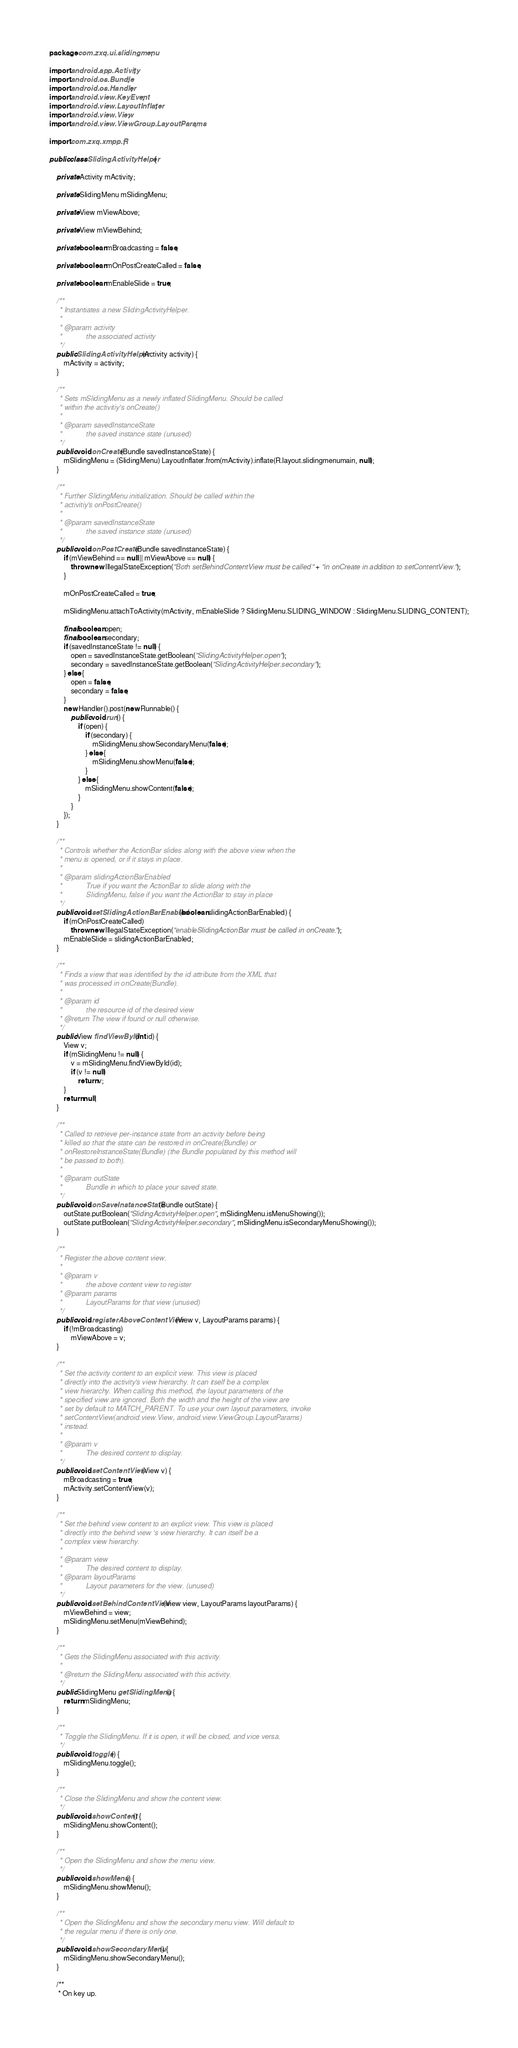<code> <loc_0><loc_0><loc_500><loc_500><_Java_>package com.zxq.ui.slidingmenu;

import android.app.Activity;
import android.os.Bundle;
import android.os.Handler;
import android.view.KeyEvent;
import android.view.LayoutInflater;
import android.view.View;
import android.view.ViewGroup.LayoutParams;

import com.zxq.xmpp.R;

public class SlidingActivityHelper {

	private Activity mActivity;

	private SlidingMenu mSlidingMenu;

	private View mViewAbove;

	private View mViewBehind;

	private boolean mBroadcasting = false;

	private boolean mOnPostCreateCalled = false;

	private boolean mEnableSlide = true;

	/**
	 * Instantiates a new SlidingActivityHelper.
	 * 
	 * @param activity
	 *            the associated activity
	 */
	public SlidingActivityHelper(Activity activity) {
		mActivity = activity;
	}

	/**
	 * Sets mSlidingMenu as a newly inflated SlidingMenu. Should be called
	 * within the activitiy's onCreate()
	 * 
	 * @param savedInstanceState
	 *            the saved instance state (unused)
	 */
	public void onCreate(Bundle savedInstanceState) {
		mSlidingMenu = (SlidingMenu) LayoutInflater.from(mActivity).inflate(R.layout.slidingmenumain, null);
	}

	/**
	 * Further SlidingMenu initialization. Should be called within the
	 * activitiy's onPostCreate()
	 * 
	 * @param savedInstanceState
	 *            the saved instance state (unused)
	 */
	public void onPostCreate(Bundle savedInstanceState) {
		if (mViewBehind == null || mViewAbove == null) {
			throw new IllegalStateException("Both setBehindContentView must be called " + "in onCreate in addition to setContentView.");
		}

		mOnPostCreateCalled = true;

		mSlidingMenu.attachToActivity(mActivity, mEnableSlide ? SlidingMenu.SLIDING_WINDOW : SlidingMenu.SLIDING_CONTENT);

		final boolean open;
		final boolean secondary;
		if (savedInstanceState != null) {
			open = savedInstanceState.getBoolean("SlidingActivityHelper.open");
			secondary = savedInstanceState.getBoolean("SlidingActivityHelper.secondary");
		} else {
			open = false;
			secondary = false;
		}
		new Handler().post(new Runnable() {
			public void run() {
				if (open) {
					if (secondary) {
						mSlidingMenu.showSecondaryMenu(false);
					} else {
						mSlidingMenu.showMenu(false);
					}
				} else {
					mSlidingMenu.showContent(false);
				}
			}
		});
	}

	/**
	 * Controls whether the ActionBar slides along with the above view when the
	 * menu is opened, or if it stays in place.
	 * 
	 * @param slidingActionBarEnabled
	 *            True if you want the ActionBar to slide along with the
	 *            SlidingMenu, false if you want the ActionBar to stay in place
	 */
	public void setSlidingActionBarEnabled(boolean slidingActionBarEnabled) {
		if (mOnPostCreateCalled)
			throw new IllegalStateException("enableSlidingActionBar must be called in onCreate.");
		mEnableSlide = slidingActionBarEnabled;
	}

	/**
	 * Finds a view that was identified by the id attribute from the XML that
	 * was processed in onCreate(Bundle).
	 * 
	 * @param id
	 *            the resource id of the desired view
	 * @return The view if found or null otherwise.
	 */
	public View findViewById(int id) {
		View v;
		if (mSlidingMenu != null) {
			v = mSlidingMenu.findViewById(id);
			if (v != null)
				return v;
		}
		return null;
	}

	/**
	 * Called to retrieve per-instance state from an activity before being
	 * killed so that the state can be restored in onCreate(Bundle) or
	 * onRestoreInstanceState(Bundle) (the Bundle populated by this method will
	 * be passed to both).
	 * 
	 * @param outState
	 *            Bundle in which to place your saved state.
	 */
	public void onSaveInstanceState(Bundle outState) {
		outState.putBoolean("SlidingActivityHelper.open", mSlidingMenu.isMenuShowing());
		outState.putBoolean("SlidingActivityHelper.secondary", mSlidingMenu.isSecondaryMenuShowing());
	}

	/**
	 * Register the above content view.
	 * 
	 * @param v
	 *            the above content view to register
	 * @param params
	 *            LayoutParams for that view (unused)
	 */
	public void registerAboveContentView(View v, LayoutParams params) {
		if (!mBroadcasting)
			mViewAbove = v;
	}

	/**
	 * Set the activity content to an explicit view. This view is placed
	 * directly into the activity's view hierarchy. It can itself be a complex
	 * view hierarchy. When calling this method, the layout parameters of the
	 * specified view are ignored. Both the width and the height of the view are
	 * set by default to MATCH_PARENT. To use your own layout parameters, invoke
	 * setContentView(android.view.View, android.view.ViewGroup.LayoutParams)
	 * instead.
	 * 
	 * @param v
	 *            The desired content to display.
	 */
	public void setContentView(View v) {
		mBroadcasting = true;
		mActivity.setContentView(v);
	}

	/**
	 * Set the behind view content to an explicit view. This view is placed
	 * directly into the behind view 's view hierarchy. It can itself be a
	 * complex view hierarchy.
	 * 
	 * @param view
	 *            The desired content to display.
	 * @param layoutParams
	 *            Layout parameters for the view. (unused)
	 */
	public void setBehindContentView(View view, LayoutParams layoutParams) {
		mViewBehind = view;
		mSlidingMenu.setMenu(mViewBehind);
	}

	/**
	 * Gets the SlidingMenu associated with this activity.
	 * 
	 * @return the SlidingMenu associated with this activity.
	 */
	public SlidingMenu getSlidingMenu() {
		return mSlidingMenu;
	}

	/**
	 * Toggle the SlidingMenu. If it is open, it will be closed, and vice versa.
	 */
	public void toggle() {
		mSlidingMenu.toggle();
	}

	/**
	 * Close the SlidingMenu and show the content view.
	 */
	public void showContent() {
		mSlidingMenu.showContent();
	}

	/**
	 * Open the SlidingMenu and show the menu view.
	 */
	public void showMenu() {
		mSlidingMenu.showMenu();
	}

	/**
	 * Open the SlidingMenu and show the secondary menu view. Will default to
	 * the regular menu if there is only one.
	 */
	public void showSecondaryMenu() {
		mSlidingMenu.showSecondaryMenu();
	}

	/**
	 * On key up.</code> 